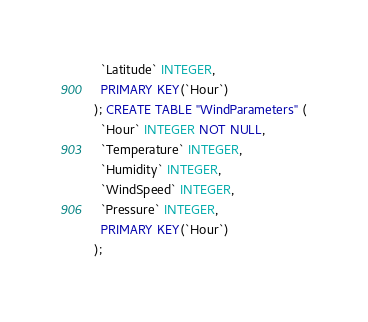Convert code to text. <code><loc_0><loc_0><loc_500><loc_500><_SQL_>  `Latitude` INTEGER,
  PRIMARY KEY(`Hour`)
); CREATE TABLE "WindParameters" (
  `Hour` INTEGER NOT NULL,
  `Temperature` INTEGER,
  `Humidity` INTEGER,
  `WindSpeed` INTEGER,
  `Pressure` INTEGER,
  PRIMARY KEY(`Hour`)
);</code> 